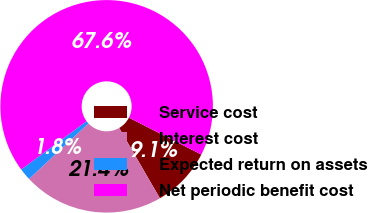Convert chart to OTSL. <chart><loc_0><loc_0><loc_500><loc_500><pie_chart><fcel>Service cost<fcel>Interest cost<fcel>Expected return on assets<fcel>Net periodic benefit cost<nl><fcel>9.15%<fcel>21.38%<fcel>1.85%<fcel>67.63%<nl></chart> 